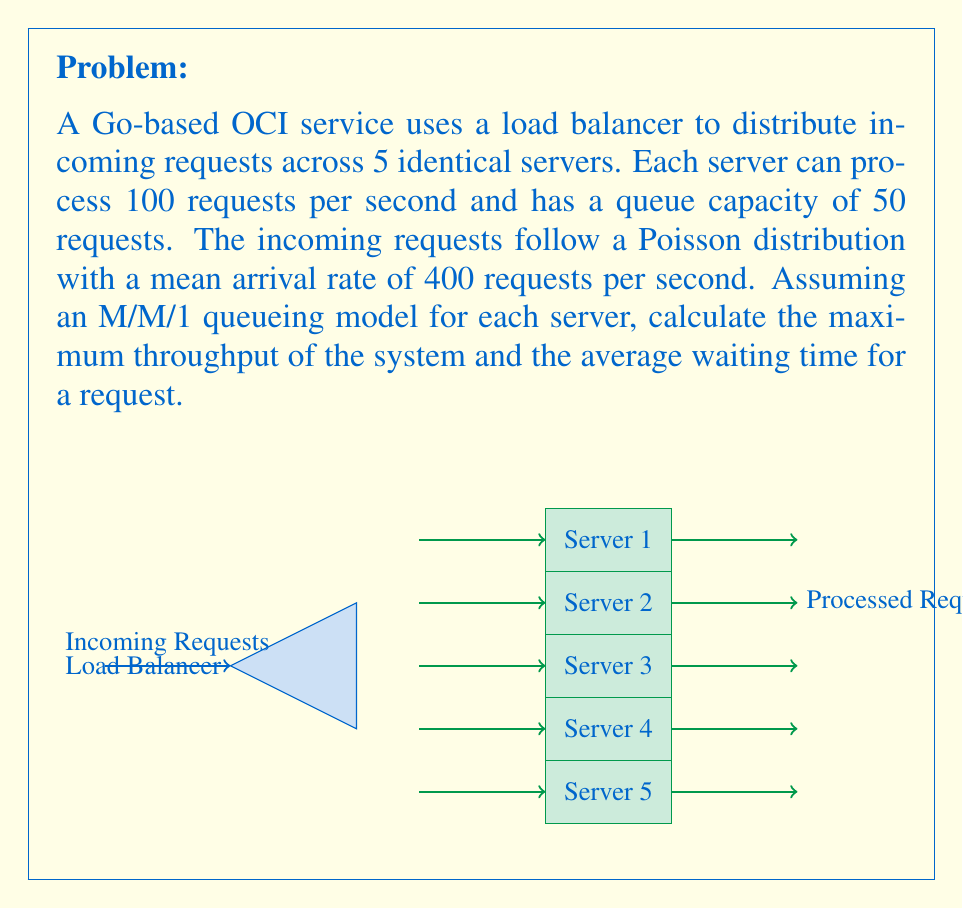Solve this math problem. To solve this problem, we'll use concepts from queueing theory and the M/M/1 model. Let's break it down step-by-step:

1. System parameters:
   - Number of servers: $n = 5$
   - Service rate per server: $\mu = 100$ requests/second
   - Total arrival rate: $\lambda = 400$ requests/second
   - Queue capacity per server: $K = 50$ requests

2. Load balancing:
   The load balancer distributes requests equally among the servers. So, each server receives:
   $$\lambda_{\text{server}} = \frac{\lambda}{n} = \frac{400}{5} = 80$$ requests/second

3. Utilization factor per server:
   $$\rho = \frac{\lambda_{\text{server}}}{\mu} = \frac{80}{100} = 0.8$$

4. Maximum throughput:
   The maximum throughput is achieved when all servers are operating at their maximum capacity:
   $$\text{Maximum Throughput} = n \times \mu = 5 \times 100 = 500$$ requests/second

5. Average waiting time:
   Using the M/M/1 queueing model formula for average waiting time:
   $$W_q = \frac{\rho}{\mu - \lambda_{\text{server}}} = \frac{0.8}{100 - 80} = \frac{0.8}{20} = 0.04$$ seconds

   The total time in the system (waiting + service) is:
   $$W = W_q + \frac{1}{\mu} = 0.04 + \frac{1}{100} = 0.05$$ seconds

Note: This calculation assumes an infinite queue. In reality, with a queue capacity of 50, there might be some request drops during peak times, slightly reducing the actual throughput. However, for the given arrival rate, the system should be stable and able to handle the load without significant drops.
Answer: Maximum Throughput: 500 requests/second
Average Waiting Time: 0.05 seconds 